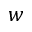Convert formula to latex. <formula><loc_0><loc_0><loc_500><loc_500>w</formula> 